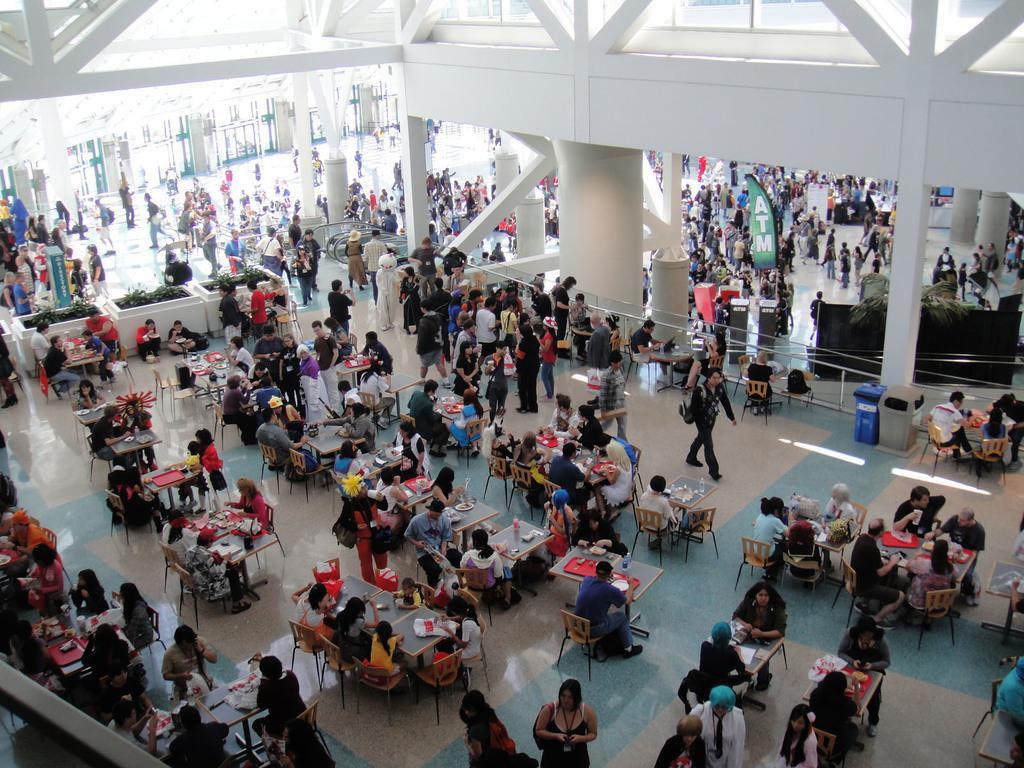Could you give a brief overview of what you see in this image? In this image, we can see the inside view of a building. Here there are so many people. Few are sitting, standing and walking. Here there are few tables and chairs on the floor. Few things and objects are placed on the tables. Background we can see pillars, plants, glass doors, banner, dustbins. 